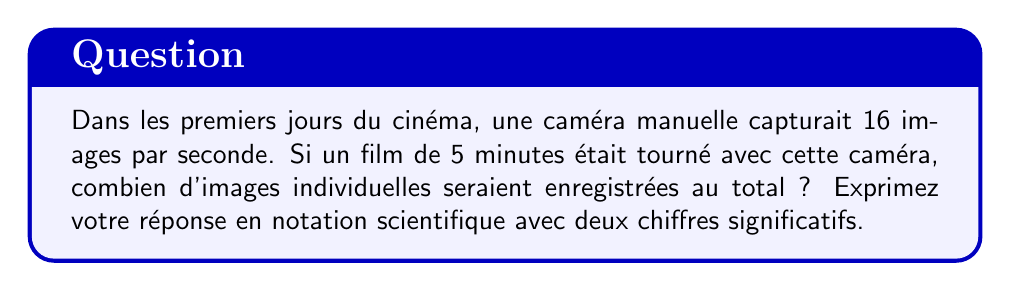Can you solve this math problem? Pour résoudre ce problème, suivons ces étapes :

1. Convertissons d'abord la durée du film en secondes :
   $5 \text{ minutes} = 5 \times 60 = 300 \text{ secondes}$

2. Calculons maintenant le nombre total d'images :
   $$\text{Nombre d'images} = \text{Images par seconde} \times \text{Nombre de secondes}$$
   $$\text{Nombre d'images} = 16 \times 300 = 4800 \text{ images}$$

3. Exprimons ce résultat en notation scientifique avec deux chiffres significatifs :
   $$4800 = 4.8 \times 10^3$$

Cette notation nous permet de voir rapidement l'ordre de grandeur du nombre d'images, ce qui est particulièrement utile pour comparer avec les techniques de cinéma modernes, où le nombre d'images par seconde est généralement plus élevé.
Answer: $4.8 \times 10^3$ images 